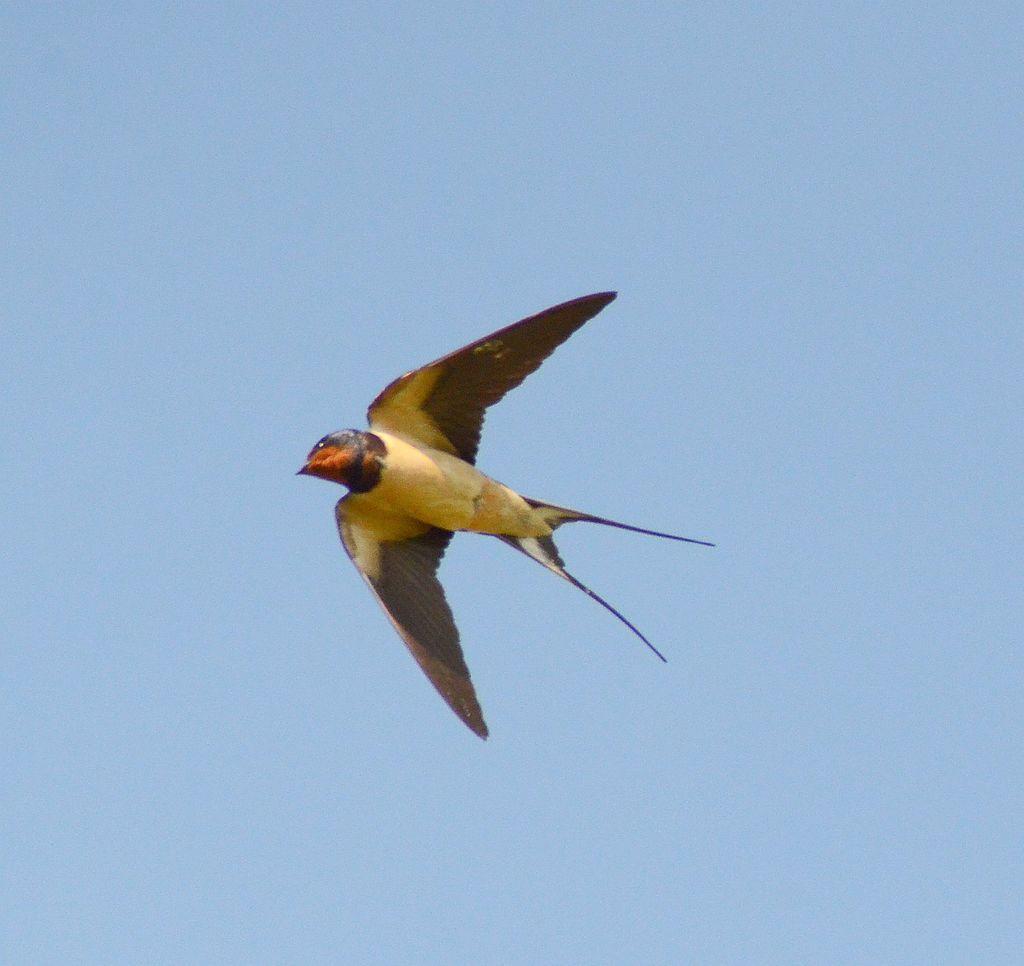Could you give a brief overview of what you see in this image? In this picture I can observe a bird flying in the air. The bird is in yellow and brown color. In the background I can observe sky. 